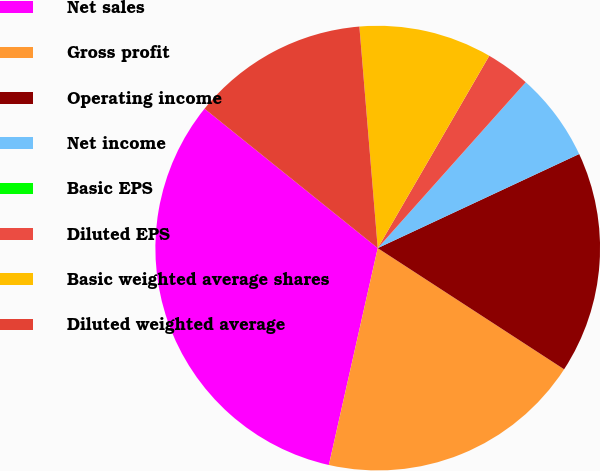Convert chart to OTSL. <chart><loc_0><loc_0><loc_500><loc_500><pie_chart><fcel>Net sales<fcel>Gross profit<fcel>Operating income<fcel>Net income<fcel>Basic EPS<fcel>Diluted EPS<fcel>Basic weighted average shares<fcel>Diluted weighted average<nl><fcel>32.26%<fcel>19.35%<fcel>16.13%<fcel>6.45%<fcel>0.0%<fcel>3.23%<fcel>9.68%<fcel>12.9%<nl></chart> 